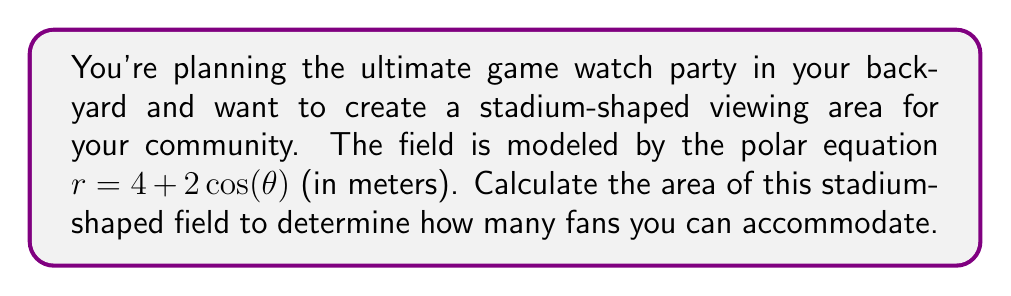Help me with this question. To calculate the area of the stadium-shaped field using polar coordinates, we'll follow these steps:

1) The general formula for the area of a region bounded by a polar curve $r = f(\theta)$ from $\theta = a$ to $\theta = b$ is:

   $$A = \frac{1}{2} \int_{a}^{b} [f(\theta)]^2 d\theta$$

2) In this case, $r = 4 + 2\cos(\theta)$, and we need to integrate from 0 to $2\pi$ to cover the entire field:

   $$A = \frac{1}{2} \int_{0}^{2\pi} [4 + 2\cos(\theta)]^2 d\theta$$

3) Expand the squared term:
   
   $$A = \frac{1}{2} \int_{0}^{2\pi} [16 + 16\cos(\theta) + 4\cos^2(\theta)] d\theta$$

4) Simplify using the identity $\cos^2(\theta) = \frac{1}{2}[1 + \cos(2\theta)]$:

   $$A = \frac{1}{2} \int_{0}^{2\pi} [16 + 16\cos(\theta) + 2 + 2\cos(2\theta)] d\theta$$
   
   $$A = \frac{1}{2} \int_{0}^{2\pi} [18 + 16\cos(\theta) + 2\cos(2\theta)] d\theta$$

5) Integrate each term:
   
   $$A = \frac{1}{2} [18\theta + 16\sin(\theta) + \sin(2\theta)]_0^{2\pi}$$

6) Evaluate the definite integral:
   
   $$A = \frac{1}{2} [(18 \cdot 2\pi + 0 + 0) - (0 + 0 + 0)]$$
   
   $$A = \frac{1}{2} \cdot 36\pi = 18\pi$$

7) Since the result is in square meters, we have:

   $$A = 18\pi \text{ m}^2$$

[asy]
import graph;
size(200);
real r(real t) {return 4+2*cos(t);}
path p=polargraph(r,0,2pi,operator ..);
draw(p);
draw(scale(0.5)*unitcircle);
draw(scale(1)*unitcircle);
draw(scale(1.5)*unitcircle);
draw(scale(2)*unitcircle);
draw(scale(2.5)*unitcircle);
draw(scale(3)*unitcircle);
draw(scale(3.5)*unitcircle);
draw(scale(4)*unitcircle);
draw(scale(4.5)*unitcircle);
draw(scale(5)*unitcircle);
draw(scale(5.5)*unitcircle);
draw(scale(6)*unitcircle);
label("0°", (6,0), E);
label("90°", (0,6), N);
label("180°", (-6,0), W);
label("270°", (0,-6), S);
[/asy]
Answer: The area of the stadium-shaped field is $18\pi \text{ m}^2$ or approximately 56.55 m². 